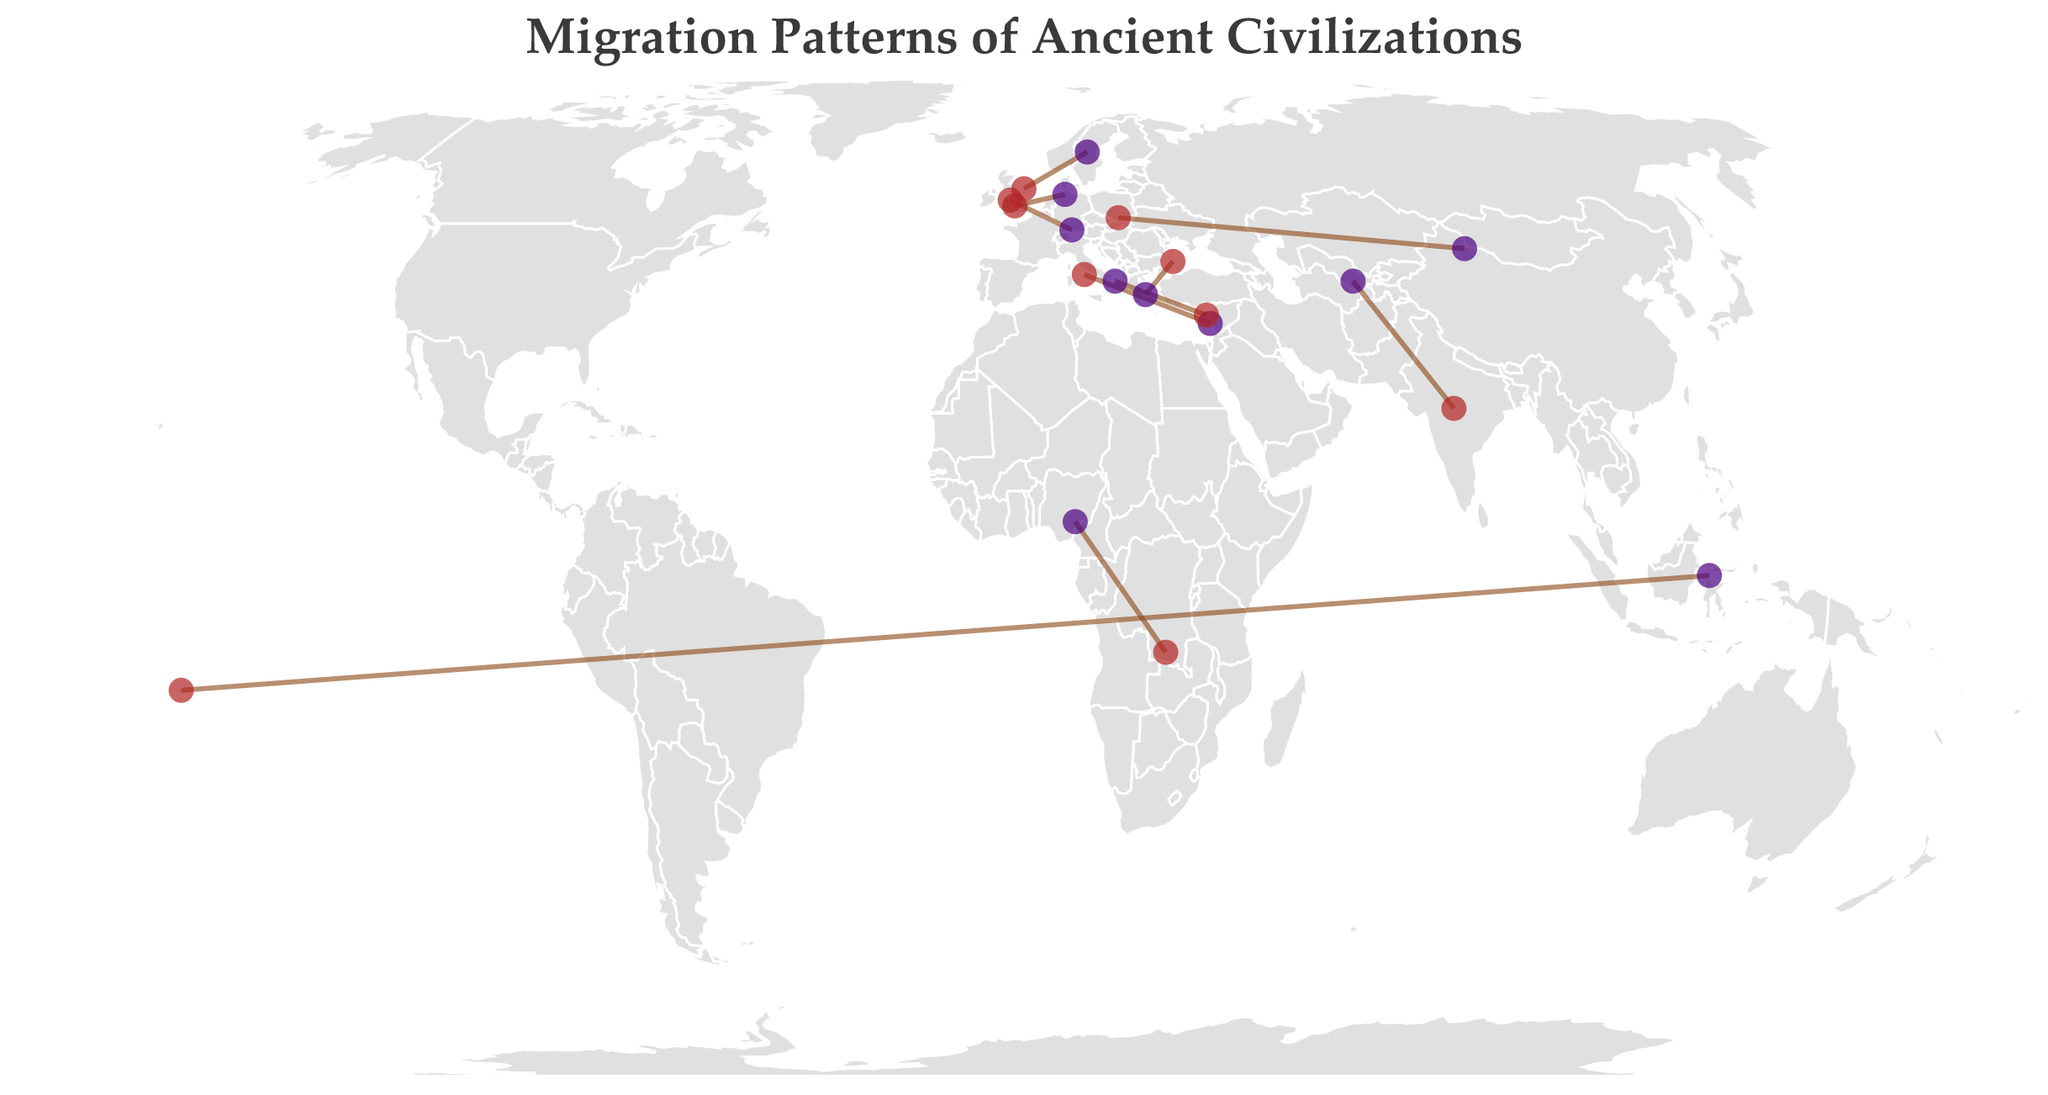What is the title of the plot? The title of the plot is located at the top part of the figure. It clearly indicates the subject of the visualized data. Looking directly at the figure, you can read the title.
Answer: Migration Patterns of Ancient Civilizations Which civilization has the longest migration period? The time periods associated with each civilization's migration are displayed as tooltips when hovering over the origin or destination markers. By considering all time periods, the Polynesians have the longest migration period, from 3000 BCE to 1200 CE.
Answer: Polynesians What's the estimated population of the Sea Peoples? The estimated population for each civilization is shown in the data points, often in the tooltip or label. The Sea Peoples have an estimated population of 400,000.
Answer: 400,000 Compare the estimated populations of the Bantu Peoples and the Celts. Which is larger, and by how much? By looking at the estimated populations indicated for both the Bantu Peoples and the Celts, we see that the Bantu Peoples have 5,000,000 and the Celts have 1,500,000. By subtracting the two, the difference is 3,500,000.
Answer: Bantu Peoples are larger by 3,500,000 Which civilization migrated to Britain and what was their estimated population? Identifying the migration destination "Britain" on the map markers and cross-referencing it with the estimated populations reveals that the Anglo-Saxons migrated to Britain with an estimated population of 200,000.
Answer: Anglo-Saxons, 200,000 What are the origin and destination regions for the Indo-Aryans? Hovering over or examining the data points for the Indo-Aryans shows their origin and destination regions as tooltips: they originated from Central Asia and migrated to the Indian Subcontinent.
Answer: Central Asia, Indian Subcontinent Which civilization migrated during the time period 370 CE - 470 CE? The migration periods are given in the tooltips. The civilization corresponding to the time period 370 CE - 470 CE are the Huns.
Answer: Huns How does the estimated population of the Vikings compare to the Sea Peoples? Checking the estimated populations, the Vikings have 500,000 and the Sea Peoples have 400,000. The Vikings have a larger estimated population by 100,000.
Answer: Vikings are larger by 100,000 Which civilization has the origin coordinates closest to the Mediterranean? Observing the origin coordinates on the map, the Phoenicians have coordinates (35.5, 33.8), placing them closest to the Mediterranean coastline.
Answer: Phoenicians Which regions did the Greek Colonists migrate from and to during 800 BCE - 600 BCE? By reviewing the data associated with the Greek Colonists, we see their migration origin as Greece and their destination regions as the Mediterranean and Black Sea.
Answer: Greece, Mediterranean and Black Sea 